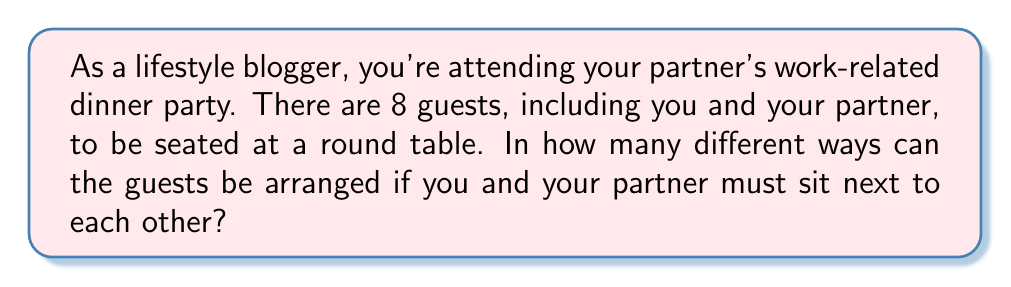What is the answer to this math problem? Let's approach this step-by-step:

1) First, consider you and your partner as a single unit. This reduces the problem to arranging 7 units around the table (you+partner as one unit, plus 6 other guests).

2) The number of ways to arrange n distinct objects in a circle is $(n-1)!$. This is because:
   - We can fix the position of one object (reducing the problem to a linear arrangement of n-1 objects).
   - The remaining n-1 objects can be arranged in $(n-1)!$ ways.

3) In this case, with 7 units, we have:
   $$(7-1)! = 6! = 720$$

4) However, you and your partner can also swap positions. This doubles the number of arrangements:
   $$720 \times 2 = 1440$$

Therefore, the total number of possible arrangements is 1440.
Answer: 1440 